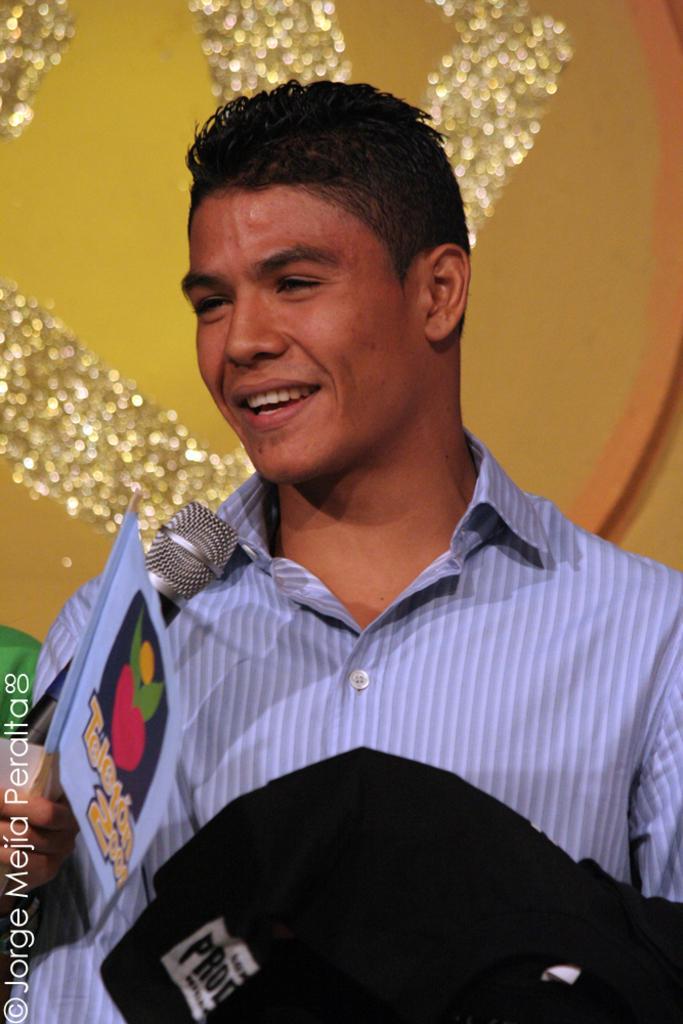In one or two sentences, can you explain what this image depicts? In this image we can see a man holding a mic and paper in his hand. 